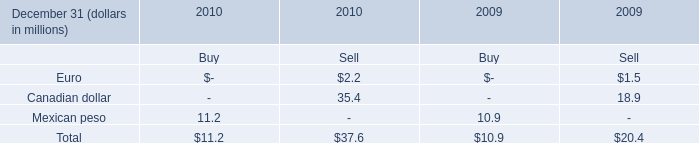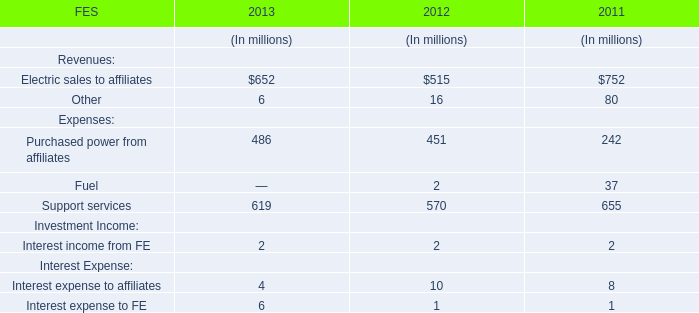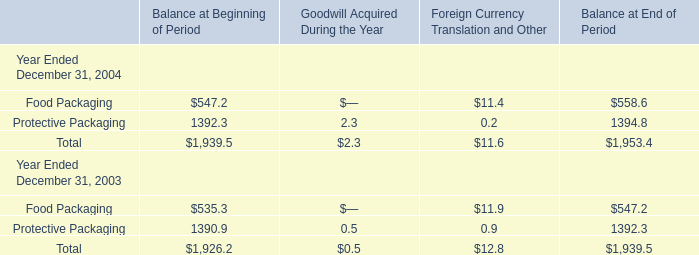What is the ratio of Food Packaging for Balance at End of Period to the total in 2003? 
Computations: (547.2 / 1939.5)
Answer: 0.28213. 